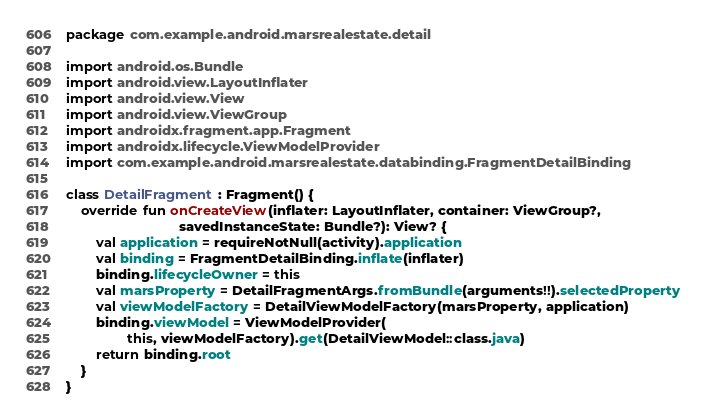<code> <loc_0><loc_0><loc_500><loc_500><_Kotlin_>package com.example.android.marsrealestate.detail

import android.os.Bundle
import android.view.LayoutInflater
import android.view.View
import android.view.ViewGroup
import androidx.fragment.app.Fragment
import androidx.lifecycle.ViewModelProvider
import com.example.android.marsrealestate.databinding.FragmentDetailBinding

class DetailFragment : Fragment() {
    override fun onCreateView(inflater: LayoutInflater, container: ViewGroup?,
                              savedInstanceState: Bundle?): View? {
        val application = requireNotNull(activity).application
        val binding = FragmentDetailBinding.inflate(inflater)
        binding.lifecycleOwner = this
        val marsProperty = DetailFragmentArgs.fromBundle(arguments!!).selectedProperty
        val viewModelFactory = DetailViewModelFactory(marsProperty, application)
        binding.viewModel = ViewModelProvider(
                this, viewModelFactory).get(DetailViewModel::class.java)
        return binding.root
    }
}
</code> 